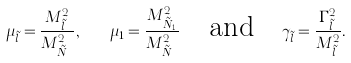<formula> <loc_0><loc_0><loc_500><loc_500>\mu _ { \tilde { l } } = \frac { M _ { \tilde { l } } ^ { 2 } } { M _ { \tilde { N } _ { a } } ^ { 2 } } , \quad \mu _ { 1 } = \frac { M _ { \tilde { N } _ { 1 } } ^ { 2 } } { M _ { \tilde { N } _ { a } } ^ { 2 } } \quad \text {and} \quad \gamma _ { \tilde { l } } = \frac { \Gamma _ { \tilde { l } } ^ { 2 } } { M _ { \tilde { l } } ^ { 2 } } .</formula> 